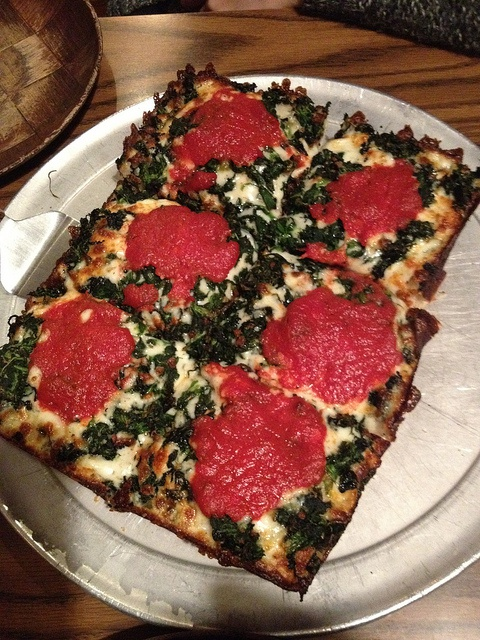Describe the objects in this image and their specific colors. I can see pizza in black, brown, maroon, and olive tones and dining table in black, maroon, and tan tones in this image. 